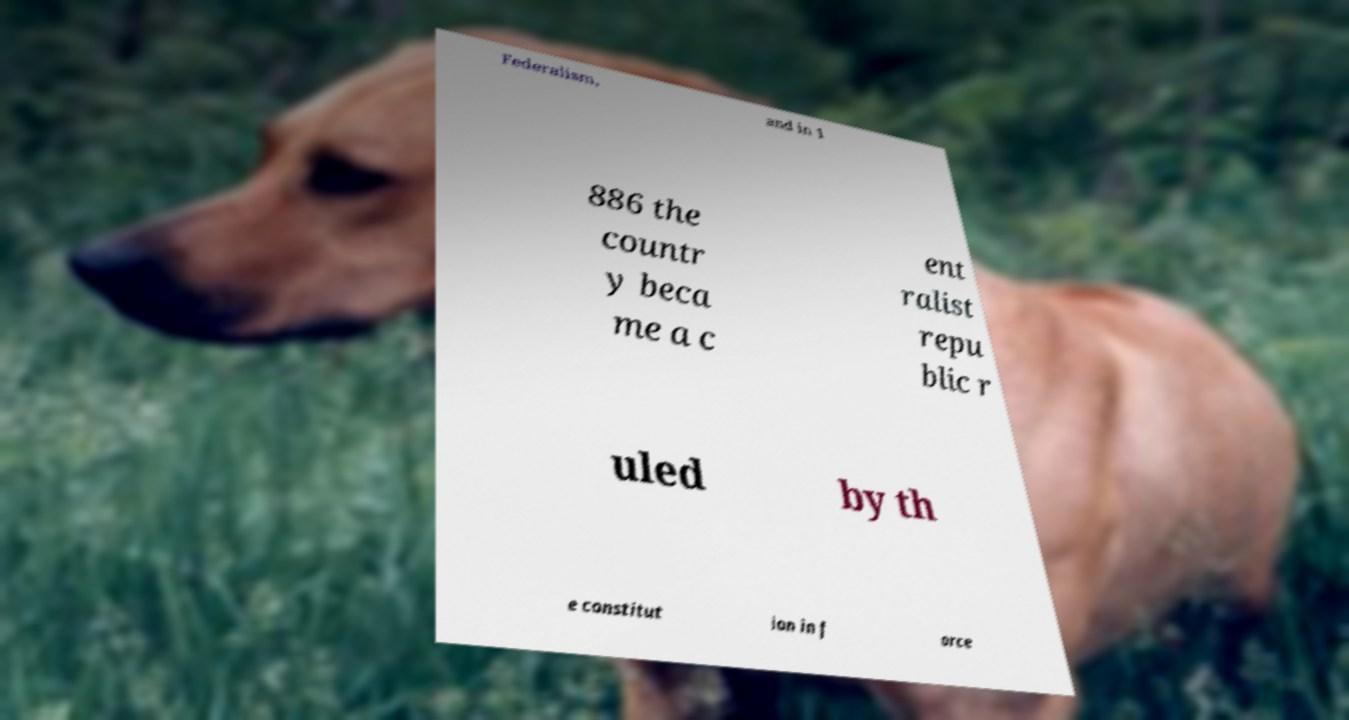Could you assist in decoding the text presented in this image and type it out clearly? Federalism, and in 1 886 the countr y beca me a c ent ralist repu blic r uled by th e constitut ion in f orce 